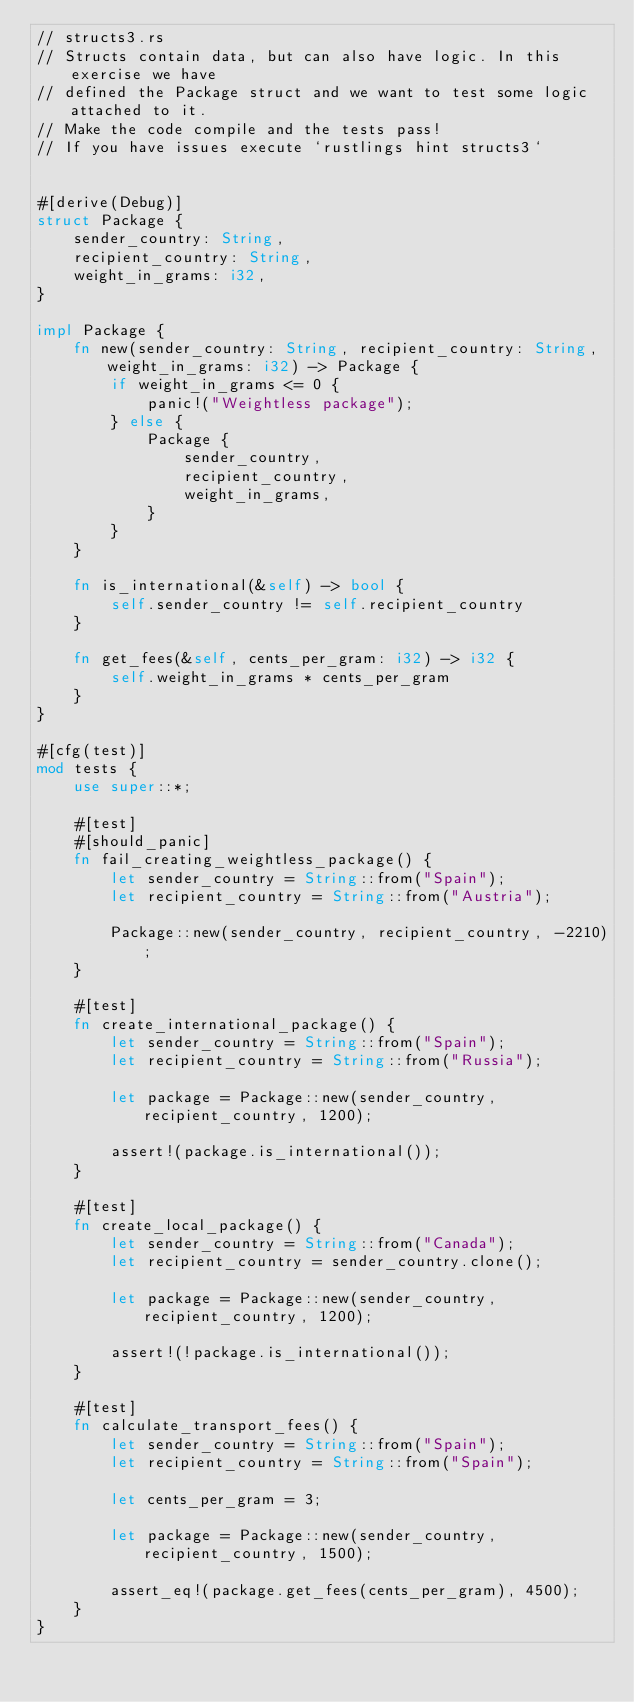Convert code to text. <code><loc_0><loc_0><loc_500><loc_500><_Rust_>// structs3.rs
// Structs contain data, but can also have logic. In this exercise we have
// defined the Package struct and we want to test some logic attached to it.
// Make the code compile and the tests pass!
// If you have issues execute `rustlings hint structs3`


#[derive(Debug)]
struct Package {
    sender_country: String,
    recipient_country: String,
    weight_in_grams: i32,
}

impl Package {
    fn new(sender_country: String, recipient_country: String, weight_in_grams: i32) -> Package {
        if weight_in_grams <= 0 {
            panic!("Weightless package");
        } else {
            Package {
                sender_country,
                recipient_country,
                weight_in_grams,
            }
        }
    }

    fn is_international(&self) -> bool {
        self.sender_country != self.recipient_country
    }

    fn get_fees(&self, cents_per_gram: i32) -> i32 {
        self.weight_in_grams * cents_per_gram
    }
}

#[cfg(test)]
mod tests {
    use super::*;

    #[test]
    #[should_panic]
    fn fail_creating_weightless_package() {
        let sender_country = String::from("Spain");
        let recipient_country = String::from("Austria");

        Package::new(sender_country, recipient_country, -2210);
    }

    #[test]
    fn create_international_package() {
        let sender_country = String::from("Spain");
        let recipient_country = String::from("Russia");

        let package = Package::new(sender_country, recipient_country, 1200);

        assert!(package.is_international());
    }

    #[test]
    fn create_local_package() {
        let sender_country = String::from("Canada");
        let recipient_country = sender_country.clone();

        let package = Package::new(sender_country, recipient_country, 1200);

        assert!(!package.is_international());
    }

    #[test]
    fn calculate_transport_fees() {
        let sender_country = String::from("Spain");
        let recipient_country = String::from("Spain");

        let cents_per_gram = 3;

        let package = Package::new(sender_country, recipient_country, 1500);

        assert_eq!(package.get_fees(cents_per_gram), 4500);
    }
}
</code> 